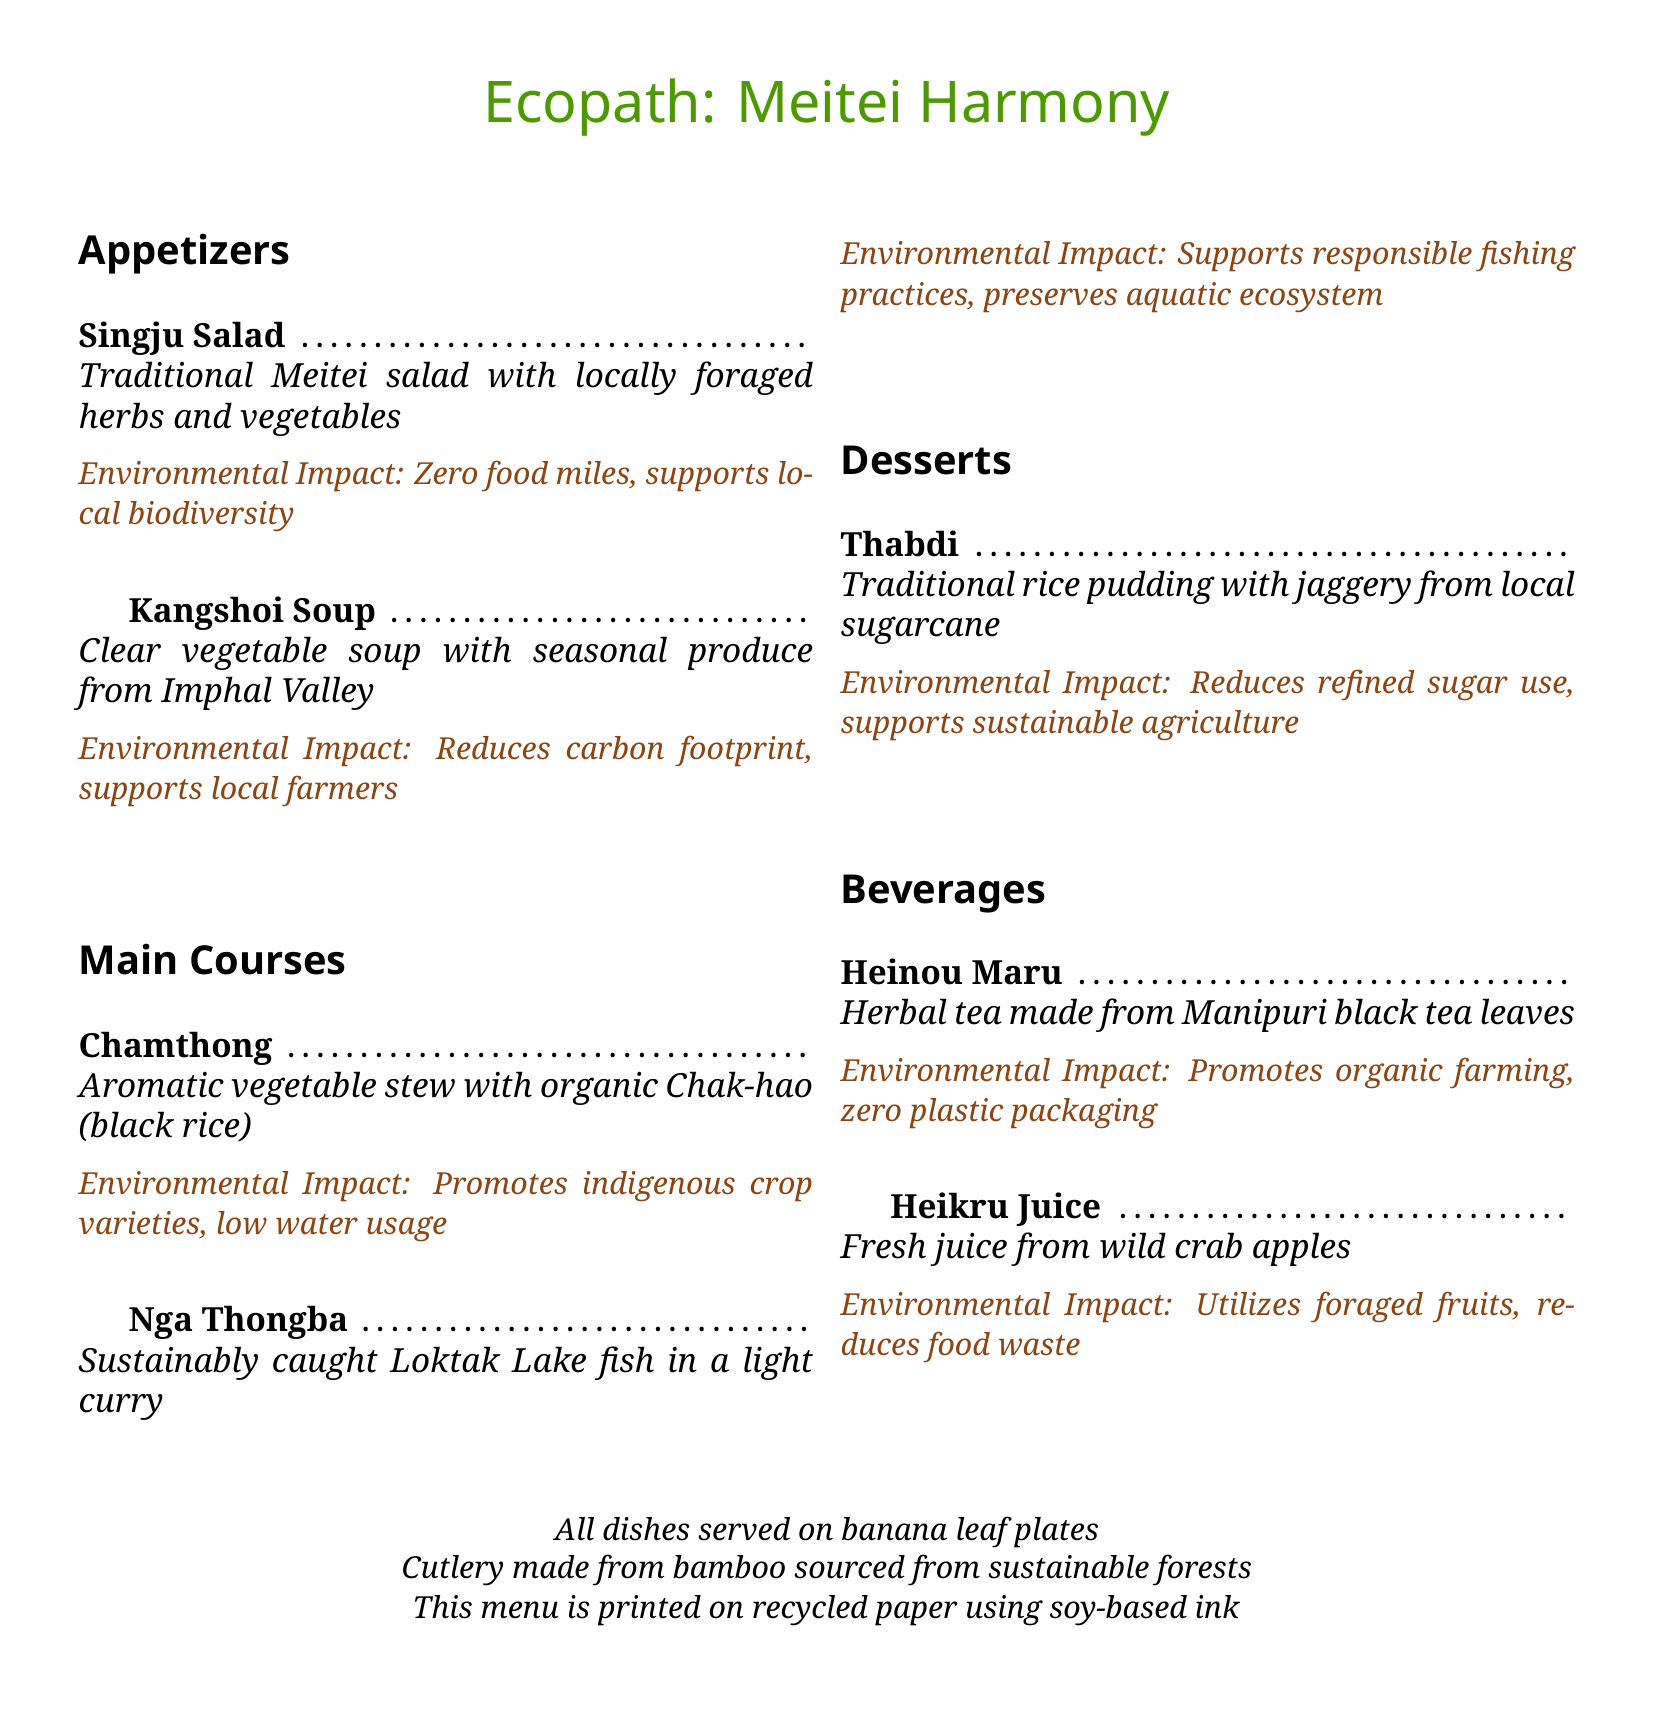What is the name of the restaurant? The name of the restaurant is prominently displayed at the top of the menu.
Answer: Ecopath: Meitei Harmony What type of cuisine does the restaurant serve? The menu description indicates the cultural style of the dishes offered.
Answer: Meitei How many appetizers are listed on the menu? The number of appetizers is counted based on the section title and items listed.
Answer: 2 What is the main ingredient of the Chamthong dish? The menu specifies the primary ingredient used in this dish.
Answer: Chak-hao (black rice) What is the environmental impact of the Nga Thongba dish? The menu provides a specific statement regarding the environmental benefits of this dish.
Answer: Supports responsible fishing practices, preserves aquatic ecosystem What material are the cutlery made from? The menunotes the sustainable material used for cutlery.
Answer: Bamboo What type of packaging is used for the herbal tea? The menu mentions the environmental aspect of the tea packaging.
Answer: Zero plastic packaging What is a unique feature of how dishes are served? The menu indicates an eco-friendly method of serving food.
Answer: Banana leaf plates What is the dessert made from? The menu describes the primary sweetener ingredient in the dessert option.
Answer: Jaggery from local sugarcane 